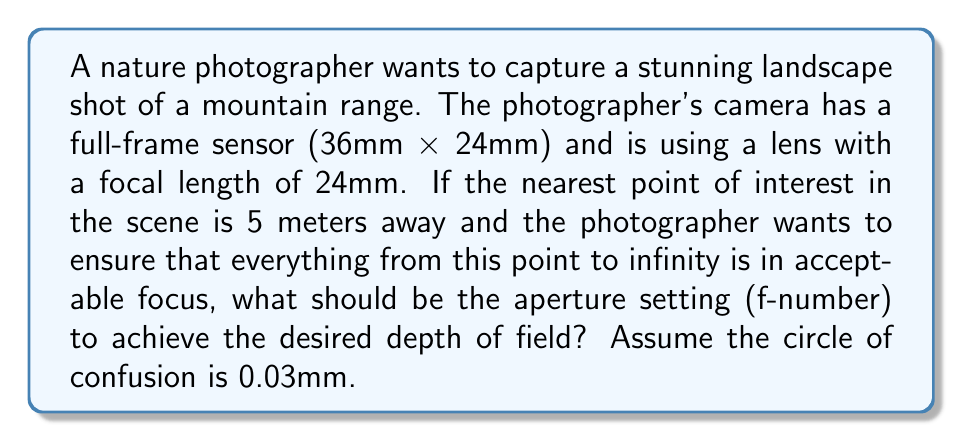What is the answer to this math problem? To solve this problem, we need to use the hyperfocal distance formula and then determine the appropriate aperture setting. Let's break it down step-by-step:

1) The hyperfocal distance (H) is given by the formula:

   $$H = \frac{f^2}{N \cdot c} + f$$

   where:
   $f$ = focal length
   $N$ = f-number (aperture)
   $c$ = circle of confusion

2) We want the nearest point of acceptable focus to be at 5 meters, which means the hyperfocal distance should be 10 meters (twice the nearest focus distance). So:

   $$10 = \frac{24^2}{N \cdot 0.03} + 24$$

3) Let's solve this equation for N:

   $$10 - 24 = \frac{24^2}{N \cdot 0.03}$$
   $$-14 = \frac{576}{0.03N}$$
   $$-0.42N = 576$$
   $$N = \frac{576}{-0.42} \approx 13.71$$

4) The closest standard f-number to 13.71 is f/14.

Therefore, to ensure that everything from 5 meters to infinity is in acceptable focus, the photographer should set the aperture to f/14.
Answer: f/14 